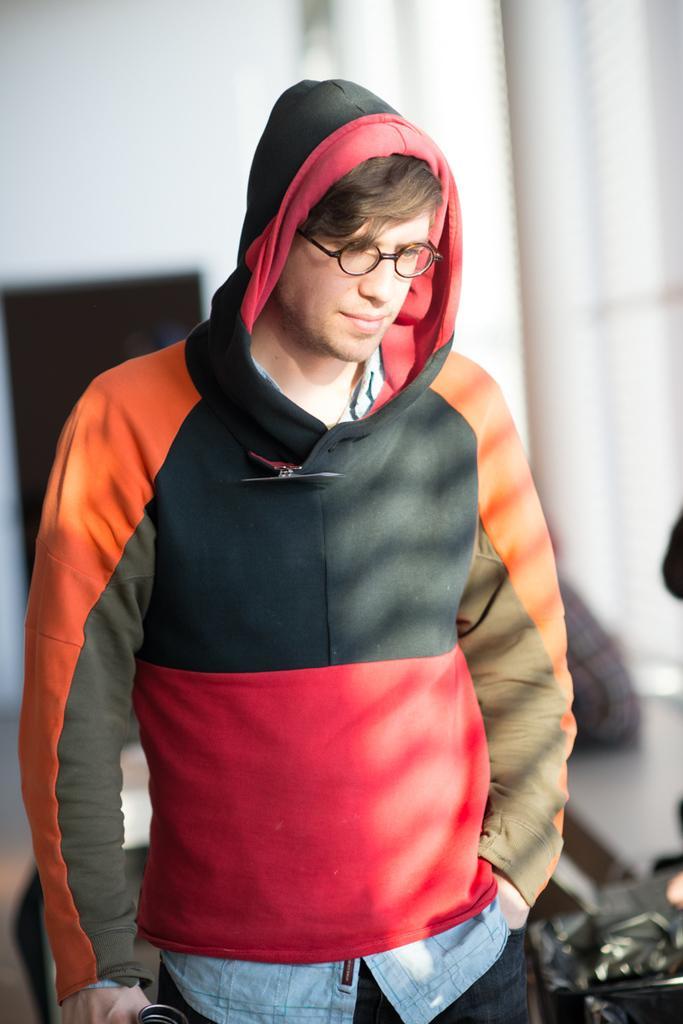How would you summarize this image in a sentence or two? In this image, we can see a person wearing clothes and spectacles on the blur background. 